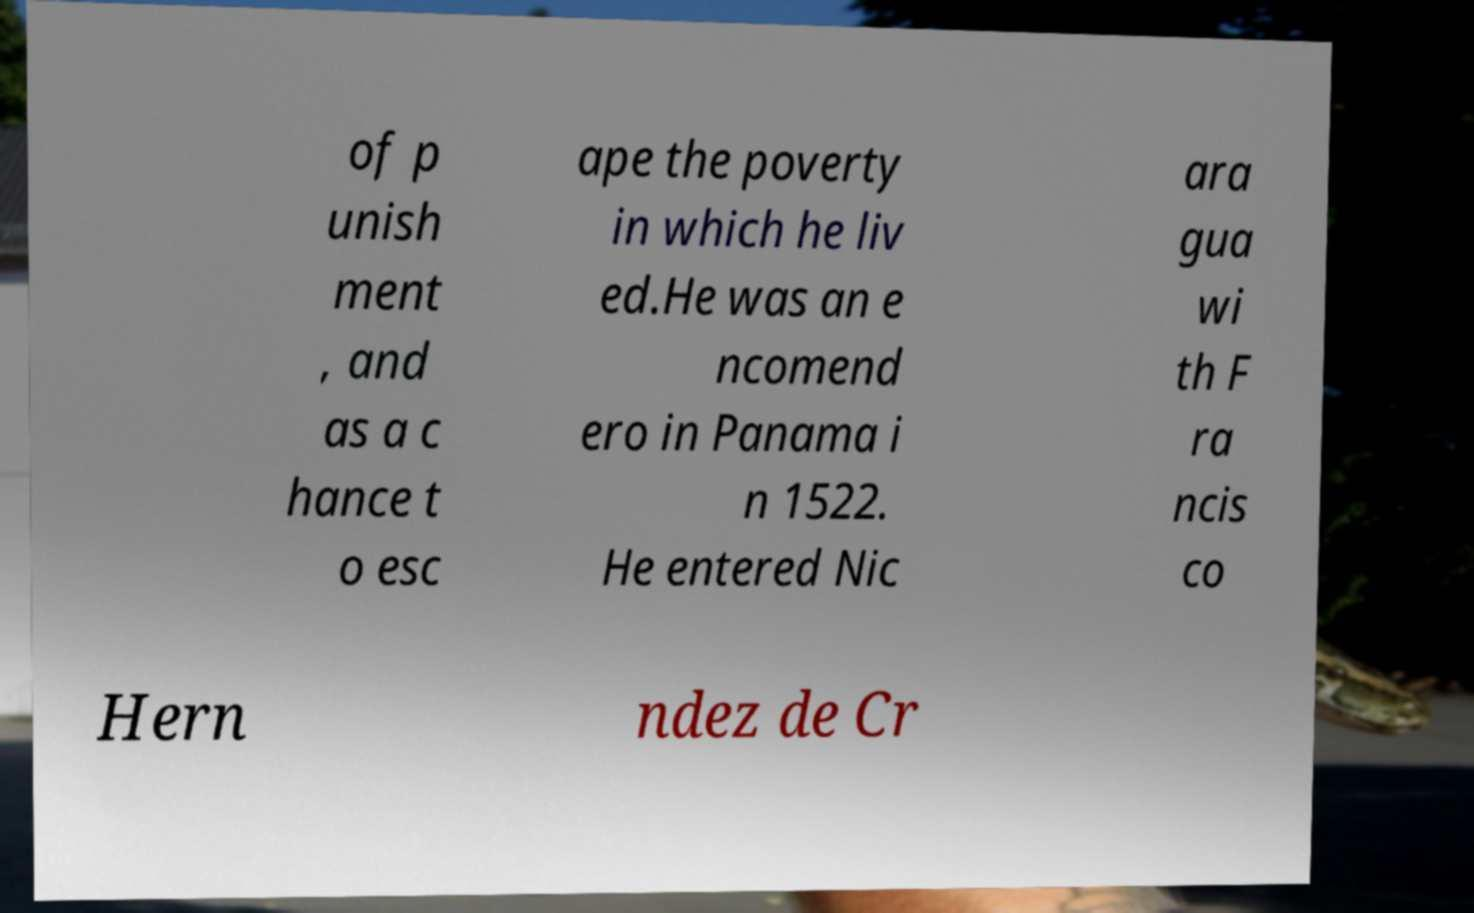Could you assist in decoding the text presented in this image and type it out clearly? of p unish ment , and as a c hance t o esc ape the poverty in which he liv ed.He was an e ncomend ero in Panama i n 1522. He entered Nic ara gua wi th F ra ncis co Hern ndez de Cr 